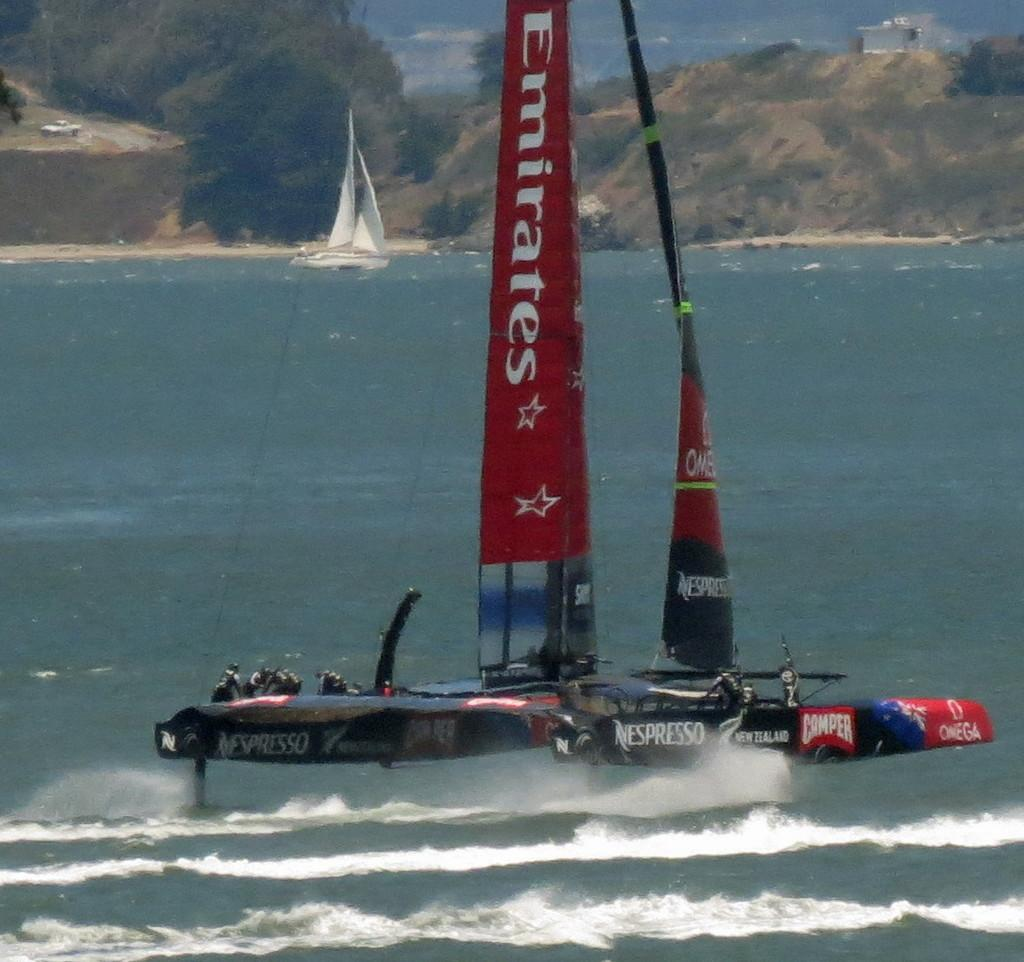What is happening on the water in the image? There are boats on the water in the image. Who is in the boats? There are people in the boats. What can be seen in the background of the image? There are hills and trees in the background of the image. Can you hear the people in the boats talking in the image? There is no sound or indication of conversation in the image, so it cannot be determined if the people are talking. 